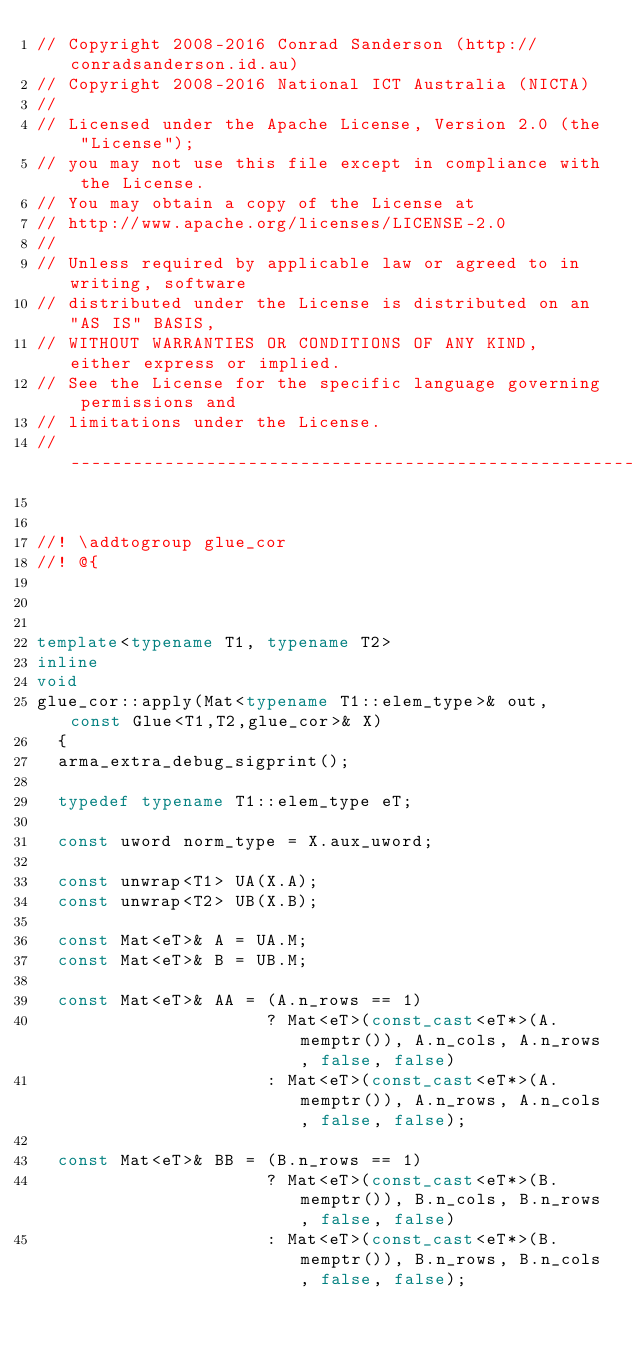Convert code to text. <code><loc_0><loc_0><loc_500><loc_500><_C++_>// Copyright 2008-2016 Conrad Sanderson (http://conradsanderson.id.au)
// Copyright 2008-2016 National ICT Australia (NICTA)
// 
// Licensed under the Apache License, Version 2.0 (the "License");
// you may not use this file except in compliance with the License.
// You may obtain a copy of the License at
// http://www.apache.org/licenses/LICENSE-2.0
// 
// Unless required by applicable law or agreed to in writing, software
// distributed under the License is distributed on an "AS IS" BASIS,
// WITHOUT WARRANTIES OR CONDITIONS OF ANY KIND, either express or implied.
// See the License for the specific language governing permissions and
// limitations under the License.
// ------------------------------------------------------------------------


//! \addtogroup glue_cor
//! @{



template<typename T1, typename T2>
inline
void
glue_cor::apply(Mat<typename T1::elem_type>& out, const Glue<T1,T2,glue_cor>& X)
  {
  arma_extra_debug_sigprint();
  
  typedef typename T1::elem_type eT;
  
  const uword norm_type = X.aux_uword;
  
  const unwrap<T1> UA(X.A);
  const unwrap<T2> UB(X.B);
  
  const Mat<eT>& A = UA.M;
  const Mat<eT>& B = UB.M;
  
  const Mat<eT>& AA = (A.n_rows == 1)
                      ? Mat<eT>(const_cast<eT*>(A.memptr()), A.n_cols, A.n_rows, false, false)
                      : Mat<eT>(const_cast<eT*>(A.memptr()), A.n_rows, A.n_cols, false, false);
  
  const Mat<eT>& BB = (B.n_rows == 1)
                      ? Mat<eT>(const_cast<eT*>(B.memptr()), B.n_cols, B.n_rows, false, false)
                      : Mat<eT>(const_cast<eT*>(B.memptr()), B.n_rows, B.n_cols, false, false);</code> 